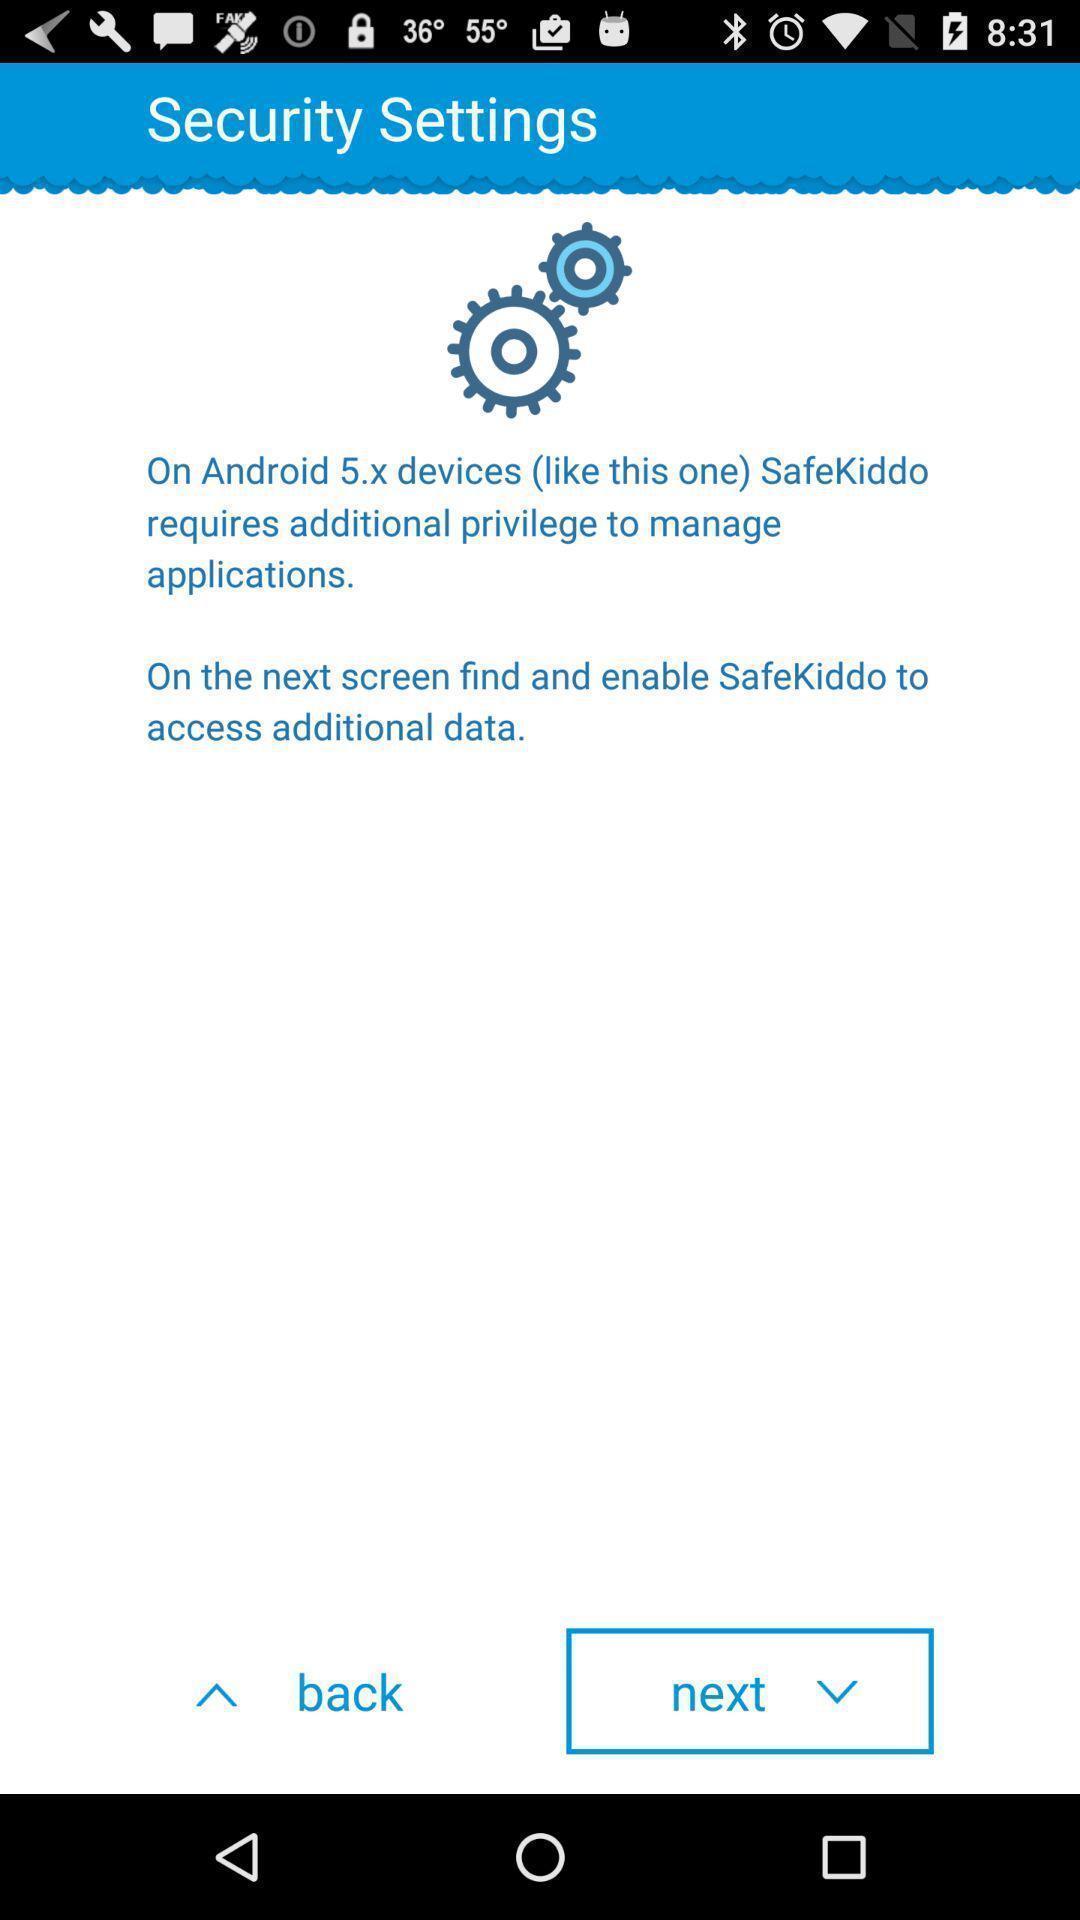Give me a narrative description of this picture. Security settings. 